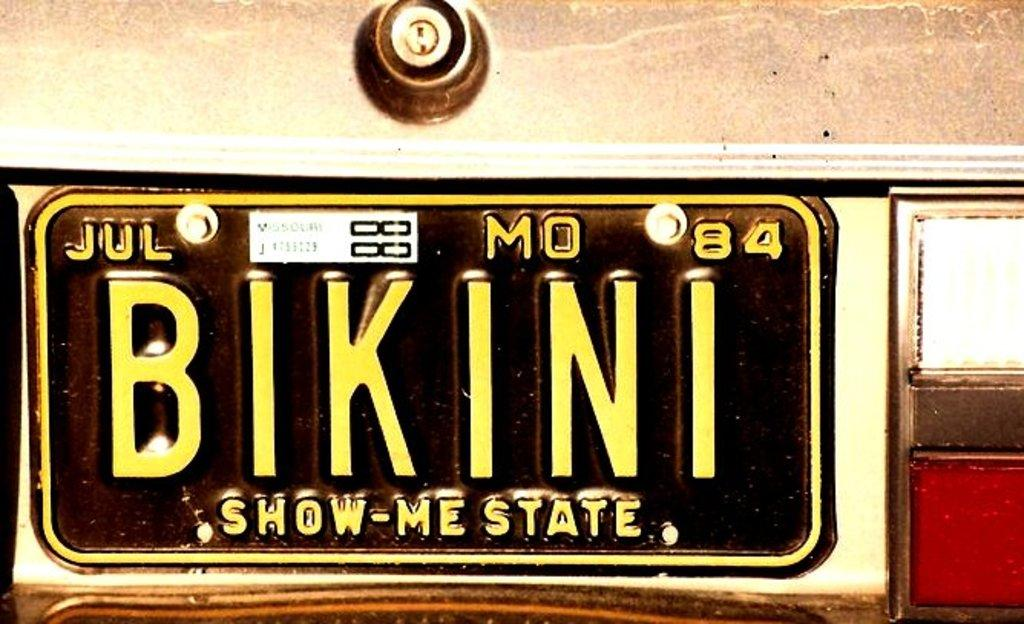<image>
Present a compact description of the photo's key features. A Missouri license plate that says BIKINI, from July 1984. 